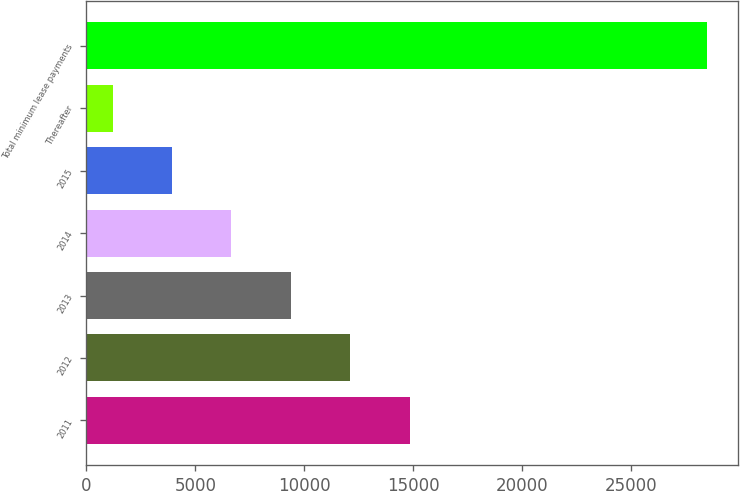Convert chart. <chart><loc_0><loc_0><loc_500><loc_500><bar_chart><fcel>2011<fcel>2012<fcel>2013<fcel>2014<fcel>2015<fcel>Thereafter<fcel>Total minimum lease payments<nl><fcel>14823.5<fcel>12097.8<fcel>9372.1<fcel>6646.4<fcel>3920.7<fcel>1195<fcel>28452<nl></chart> 